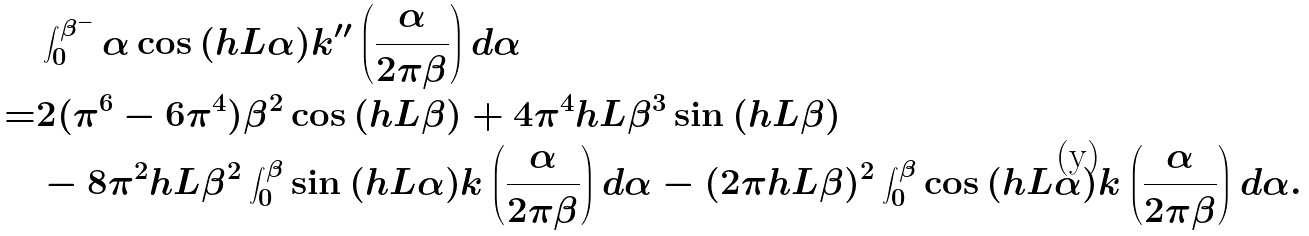<formula> <loc_0><loc_0><loc_500><loc_500>& \int _ { 0 } ^ { \beta ^ { - } } \alpha \cos { ( h L \alpha ) } k ^ { \prime \prime } \left ( \frac { \alpha } { 2 \pi \beta } \right ) d \alpha \\ = & 2 ( \pi ^ { 6 } - 6 \pi ^ { 4 } ) \beta ^ { 2 } \cos { ( h L \beta ) } + 4 \pi ^ { 4 } h L \beta ^ { 3 } \sin { ( h L \beta ) } \\ & - 8 \pi ^ { 2 } h L \beta ^ { 2 } \int _ { 0 } ^ { \beta } \sin { ( h L \alpha ) } k \left ( \frac { \alpha } { 2 \pi \beta } \right ) d \alpha - ( 2 \pi h L \beta ) ^ { 2 } \int _ { 0 } ^ { \beta } \cos { ( h L \alpha ) } k \left ( \frac { \alpha } { 2 \pi \beta } \right ) d \alpha .</formula> 